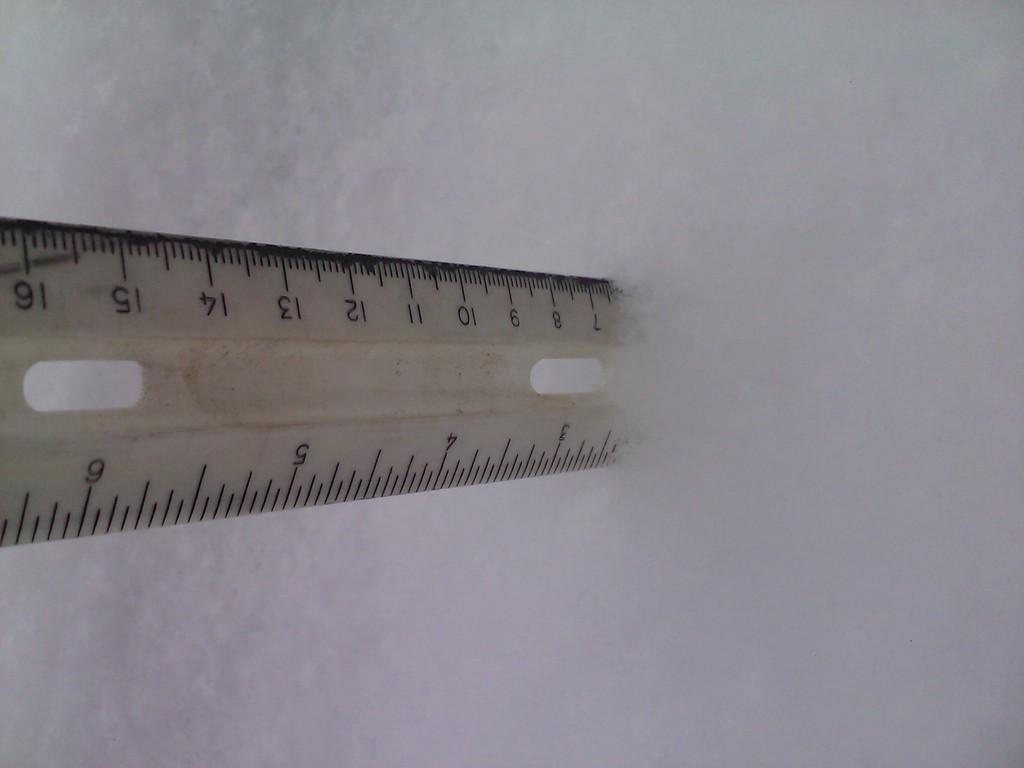What is the biggest number on the ruler?
Ensure brevity in your answer.  16. 